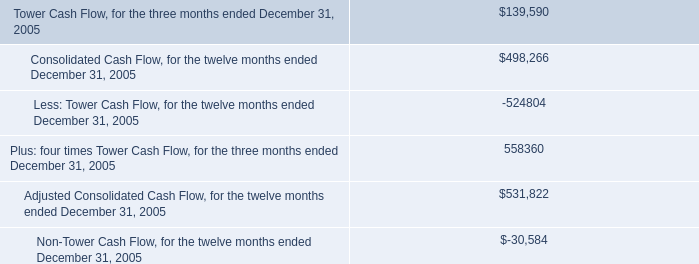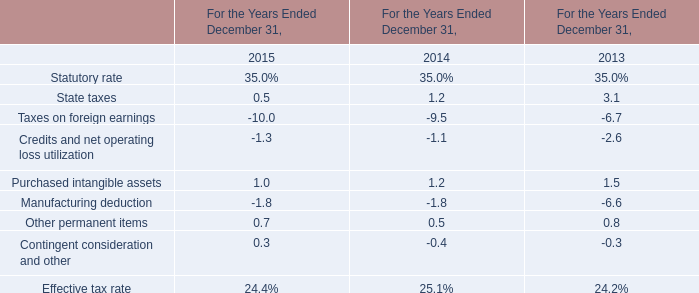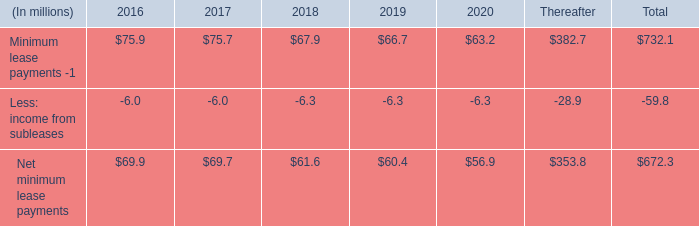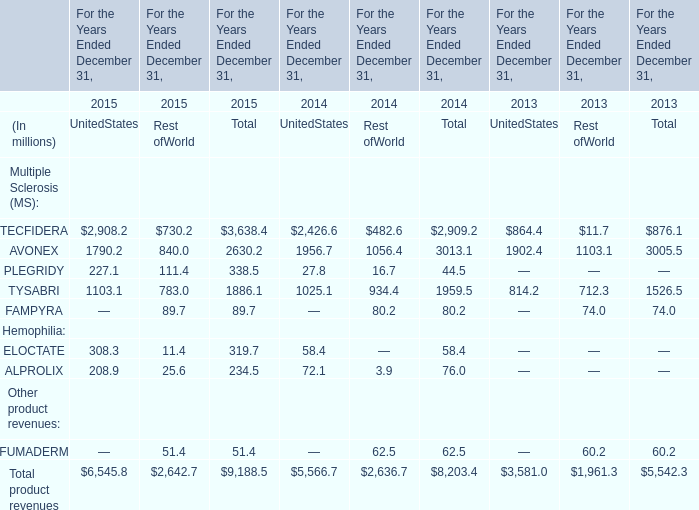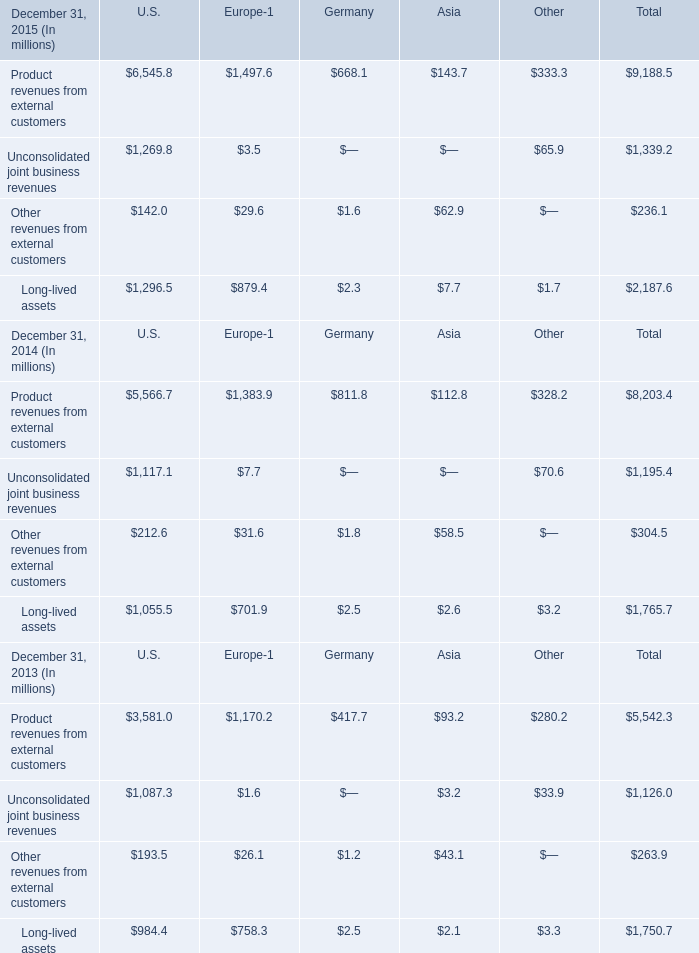The total amount of which section in 2015 ranks first? 
Answer: Product revenues from external customers. 